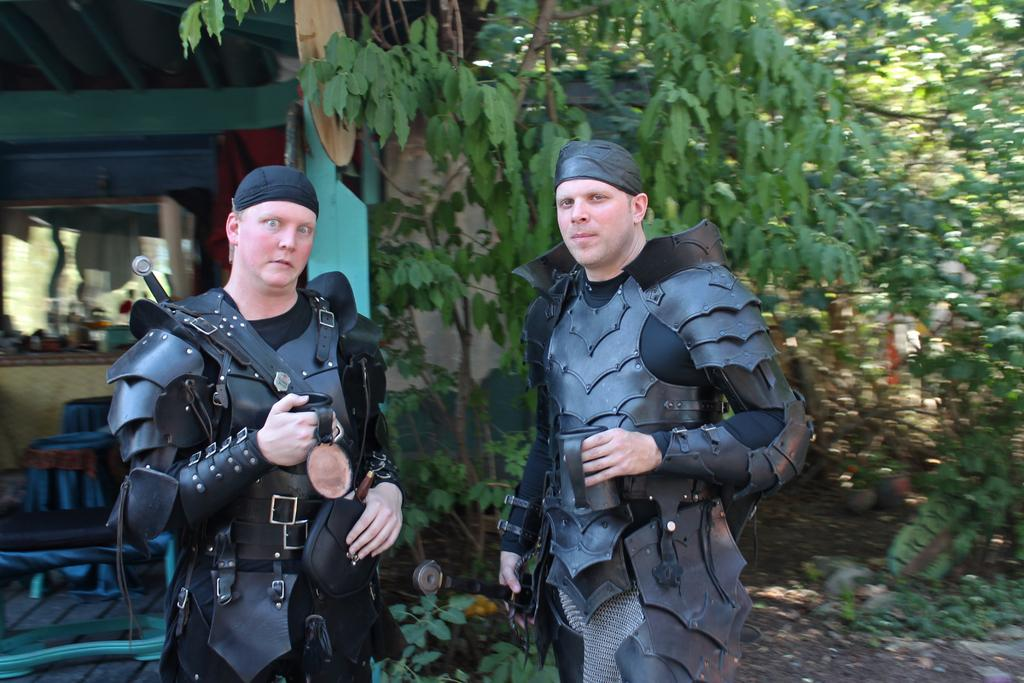How many people are in the image? There are two persons in the image. What are the persons doing in the image? The persons are standing on the ground. What are the persons wearing in the image? The persons are wearing costumes. What can be seen in the background of the image? There are trees, chairs, and objects placed on a table in the background of the image. How many surprises are hidden in the costumes of the persons in the image? There is no indication in the image that there are any surprises hidden in the costumes of the persons. Can you provide an example of an object placed on the table in the background of the image? The image does not provide a clear view of the objects placed on the table, so it is not possible to give an example. 